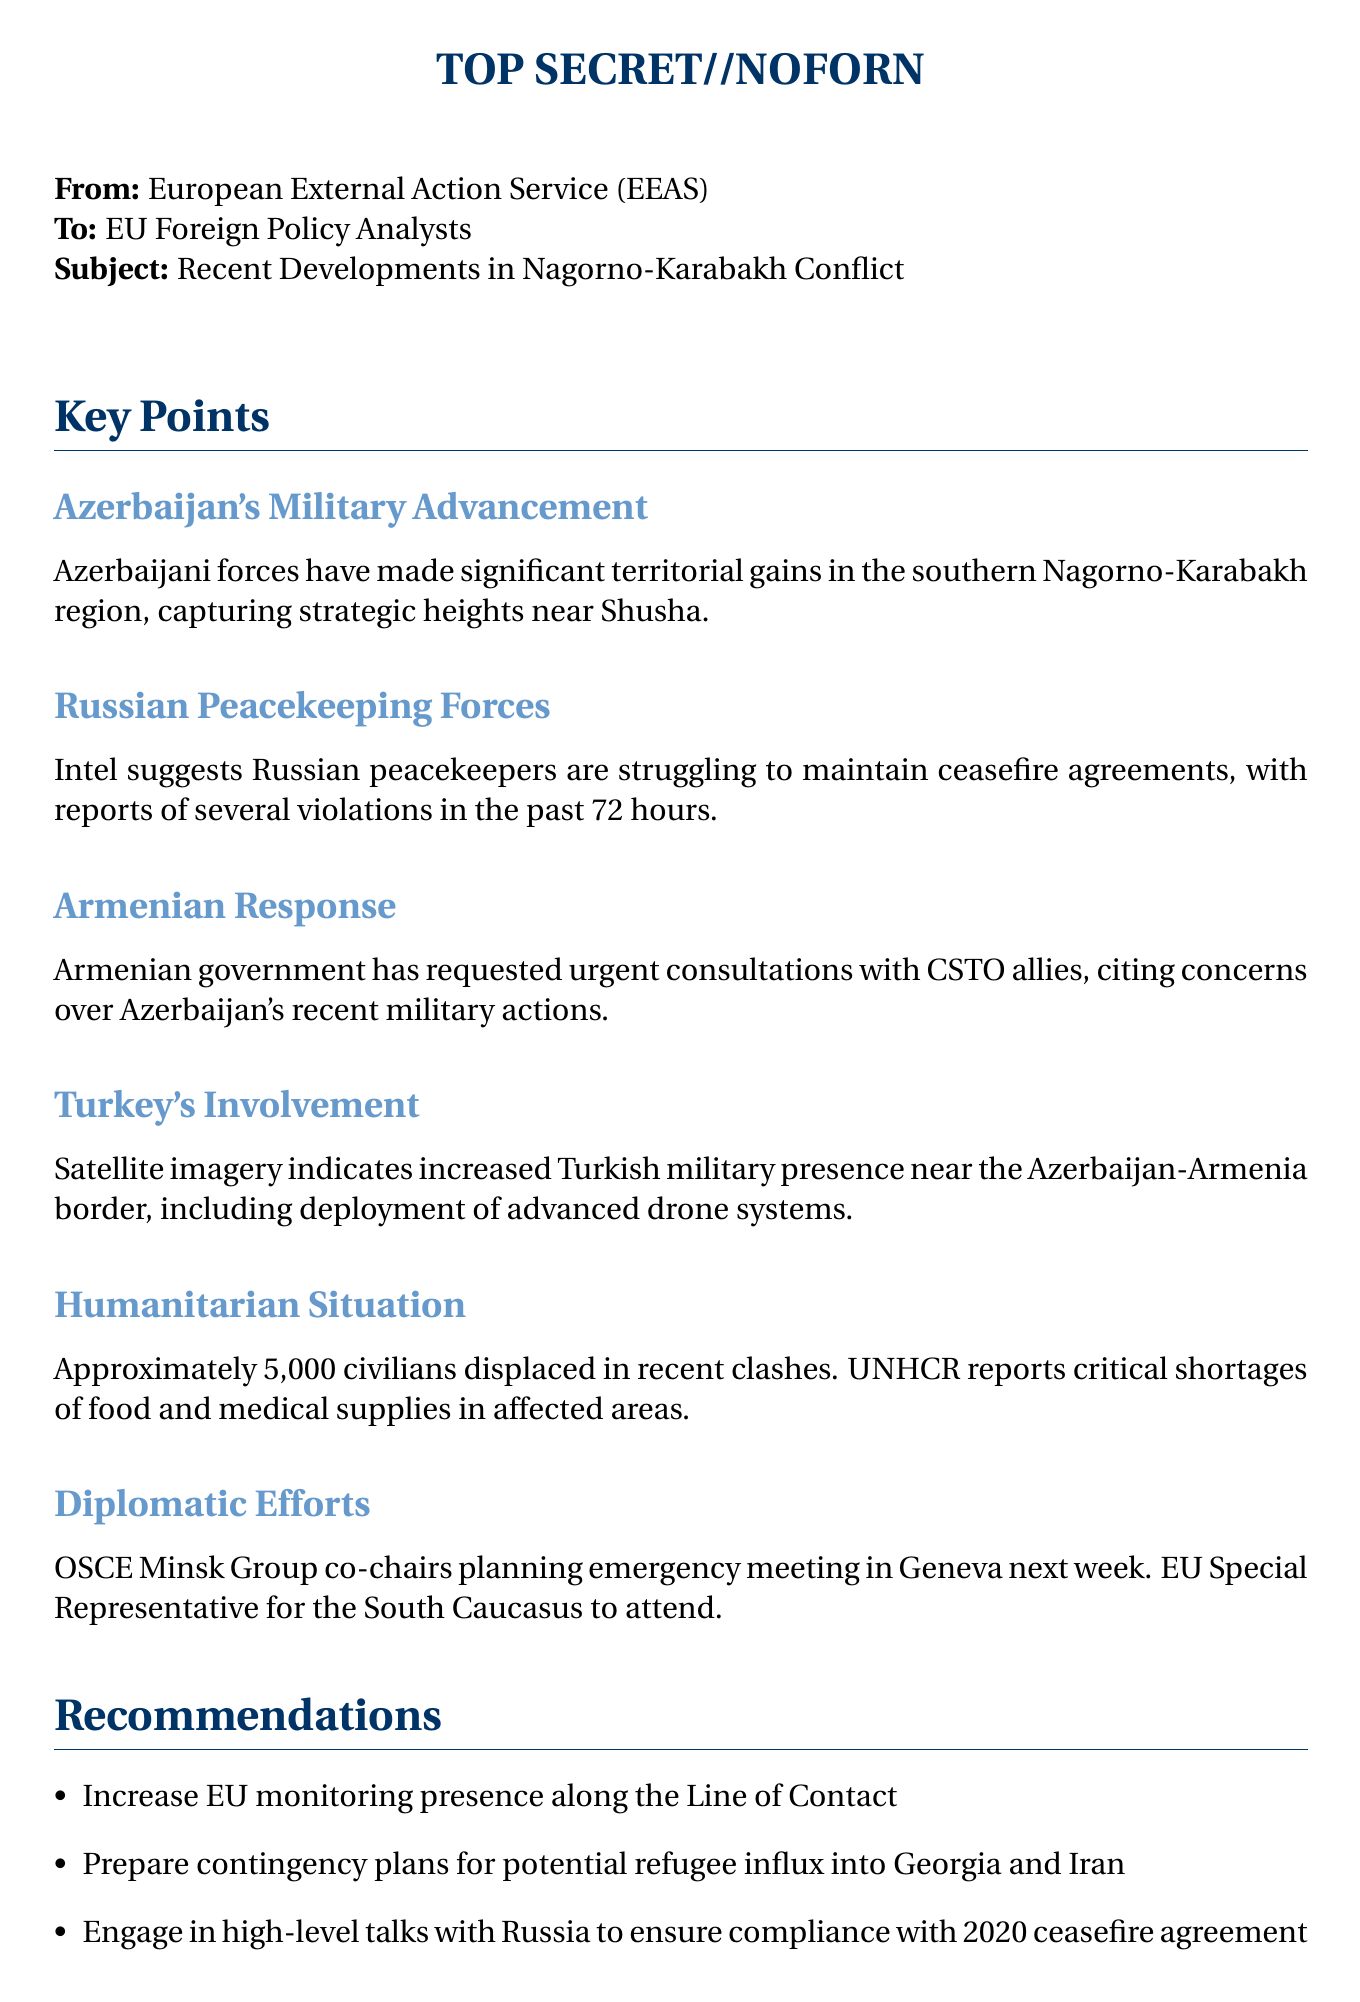What recent gains have Azerbaijani forces made? The document states that Azerbaijani forces have captured strategic heights near Shusha.
Answer: strategic heights near Shusha What is the humanitarian situation reported in the document? The document mentions that approximately 5,000 civilians are displaced due to recent clashes.
Answer: approximately 5,000 civilians displaced When is the emergency meeting in Geneva planned? The document specifies that the emergency meeting is scheduled for next week.
Answer: next week Which organization is planning the emergency meeting? The document indicates that the OSCE Minsk Group co-chairs are planning the emergency meeting.
Answer: OSCE Minsk Group What is the date of the document? The document provides the date as 15 September 2023.
Answer: 15 September 2023 What kind of military presence has Turkey increased? The document notes that there is an increased Turkish military presence, including advanced drone systems.
Answer: advanced drone systems What has the Armenian government requested? The document states that Armenia has requested urgent consultations with CSTO allies.
Answer: urgent consultations with CSTO allies What is one of the recommendations made in the document? The document recommends increasing EU monitoring presence along the Line of Contact.
Answer: increase EU monitoring presence along the Line of Contact 